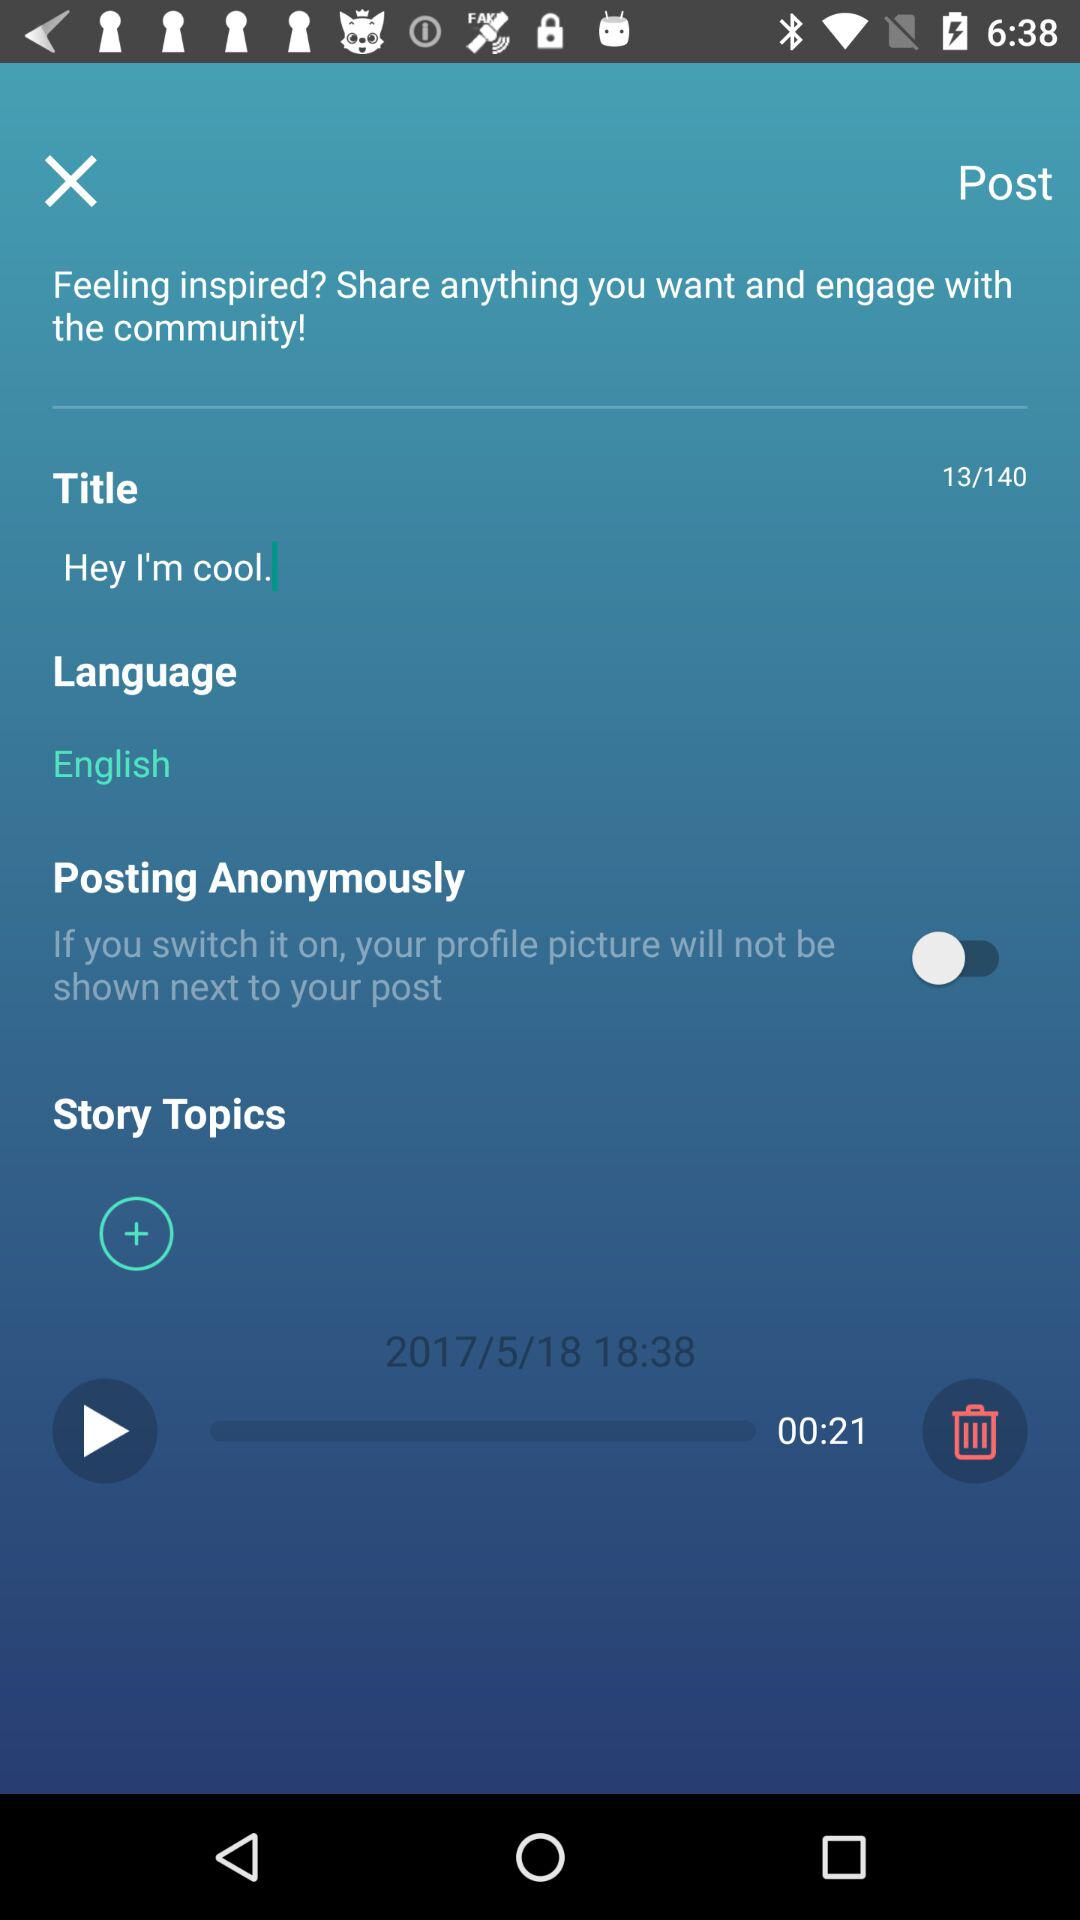What is the language? The language is English. 